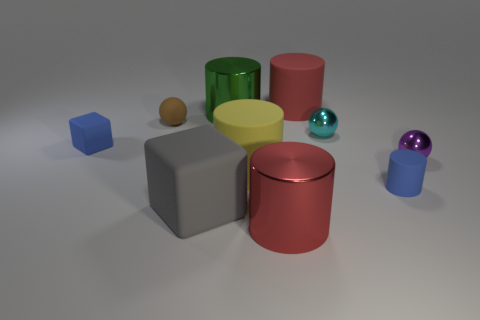Subtract all rubber balls. How many balls are left? 2 Subtract all blue cubes. How many cubes are left? 1 Subtract all balls. How many objects are left? 7 Add 6 big yellow matte cylinders. How many big yellow matte cylinders are left? 7 Add 1 cylinders. How many cylinders exist? 6 Subtract 0 purple cylinders. How many objects are left? 10 Subtract all gray blocks. Subtract all gray spheres. How many blocks are left? 1 Subtract all cyan blocks. How many cyan cylinders are left? 0 Subtract all big rubber things. Subtract all gray rubber objects. How many objects are left? 6 